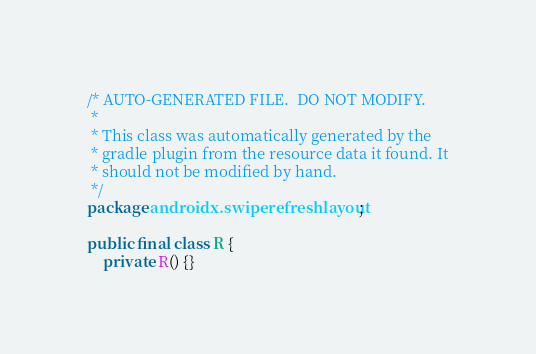Convert code to text. <code><loc_0><loc_0><loc_500><loc_500><_Java_>/* AUTO-GENERATED FILE.  DO NOT MODIFY.
 *
 * This class was automatically generated by the
 * gradle plugin from the resource data it found. It
 * should not be modified by hand.
 */
package androidx.swiperefreshlayout;

public final class R {
    private R() {}
</code> 